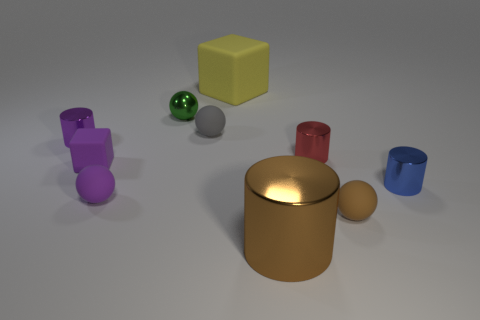Subtract 1 cylinders. How many cylinders are left? 3 Subtract all yellow cubes. Subtract all purple cylinders. How many cubes are left? 1 Subtract all spheres. How many objects are left? 6 Subtract all tiny gray spheres. Subtract all small purple shiny things. How many objects are left? 8 Add 3 tiny brown rubber things. How many tiny brown rubber things are left? 4 Add 1 large brown cylinders. How many large brown cylinders exist? 2 Subtract 1 blue cylinders. How many objects are left? 9 